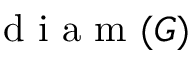<formula> <loc_0><loc_0><loc_500><loc_500>d i a m ( G )</formula> 